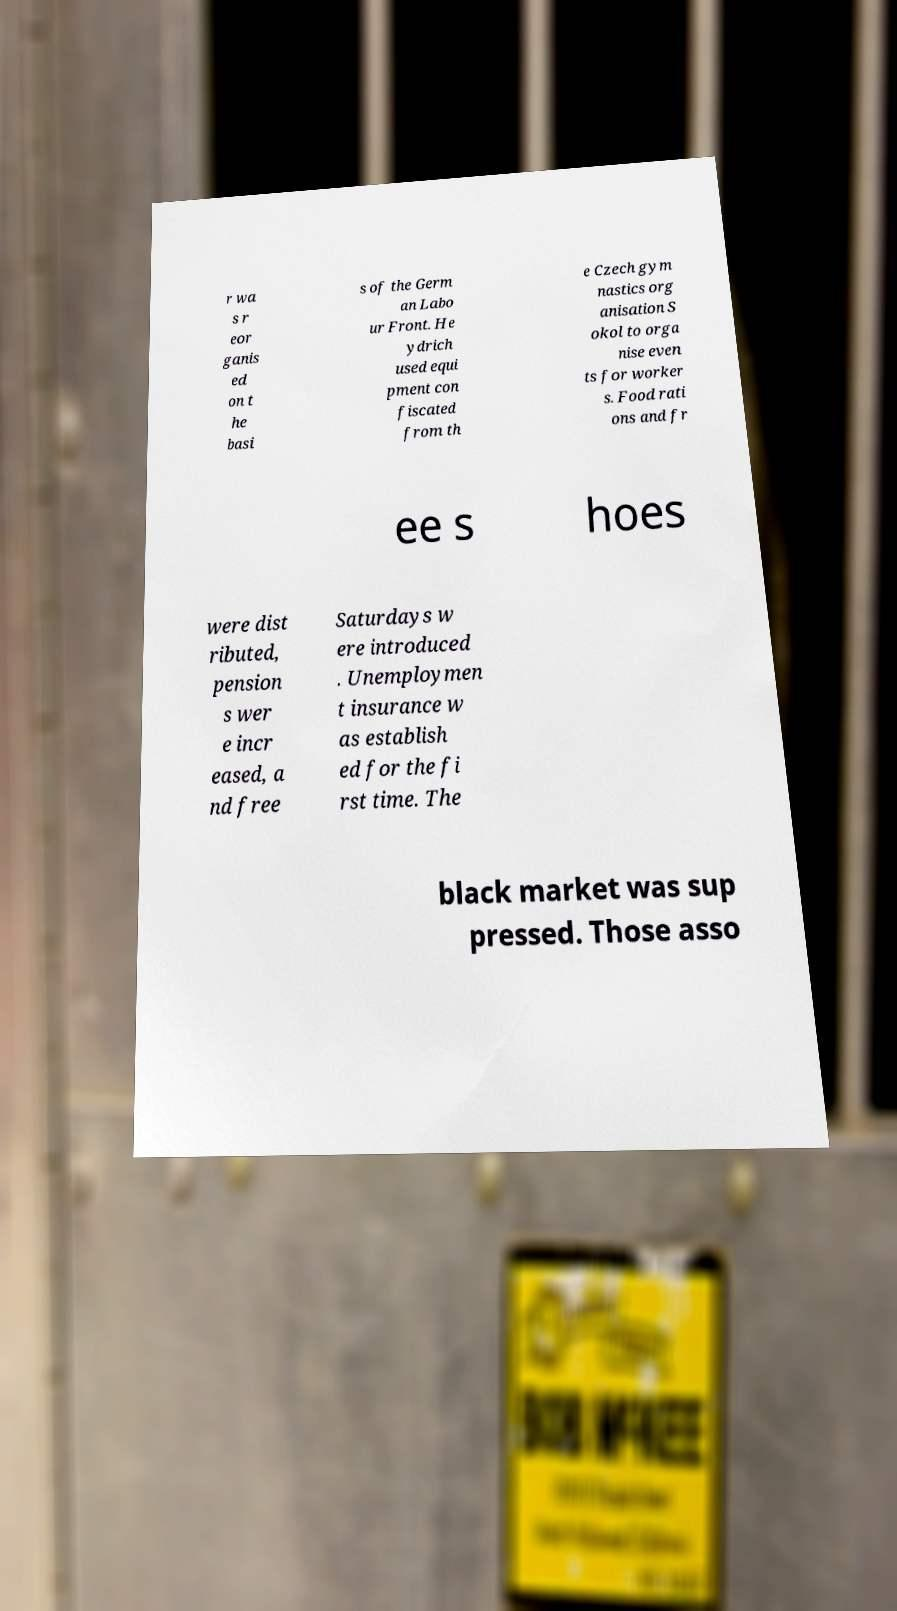Please read and relay the text visible in this image. What does it say? r wa s r eor ganis ed on t he basi s of the Germ an Labo ur Front. He ydrich used equi pment con fiscated from th e Czech gym nastics org anisation S okol to orga nise even ts for worker s. Food rati ons and fr ee s hoes were dist ributed, pension s wer e incr eased, a nd free Saturdays w ere introduced . Unemploymen t insurance w as establish ed for the fi rst time. The black market was sup pressed. Those asso 